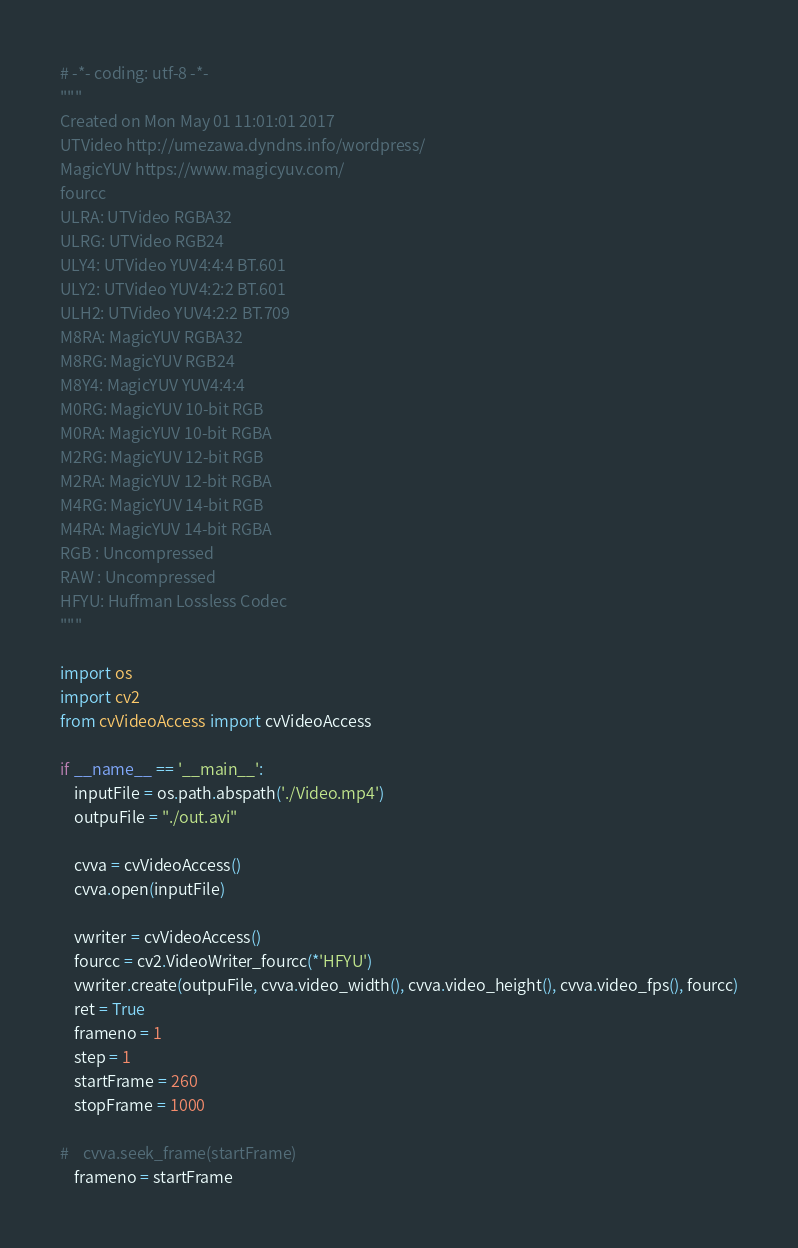Convert code to text. <code><loc_0><loc_0><loc_500><loc_500><_Python_># -*- coding: utf-8 -*-
"""
Created on Mon May 01 11:01:01 2017
UTVideo http://umezawa.dyndns.info/wordpress/
MagicYUV https://www.magicyuv.com/
fourcc 
ULRA: UTVideo RGBA32
ULRG: UTVideo RGB24
ULY4: UTVideo YUV4:4:4 BT.601
ULY2: UTVideo YUV4:2:2 BT.601
ULH2: UTVideo YUV4:2:2 BT.709
M8RA: MagicYUV RGBA32
M8RG: MagicYUV RGB24
M8Y4: MagicYUV YUV4:4:4
M0RG: MagicYUV 10-bit RGB
M0RA: MagicYUV 10-bit RGBA
M2RG: MagicYUV 12-bit RGB
M2RA: MagicYUV 12-bit RGBA
M4RG: MagicYUV 14-bit RGB
M4RA: MagicYUV 14-bit RGBA
RGB : Uncompressed
RAW : Uncompressed
HFYU: Huffman Lossless Codec
"""

import os
import cv2
from cvVideoAccess import cvVideoAccess

if __name__ == '__main__':
    inputFile = os.path.abspath('./Video.mp4')
    outpuFile = "./out.avi"

    cvva = cvVideoAccess()
    cvva.open(inputFile)

    vwriter = cvVideoAccess()
    fourcc = cv2.VideoWriter_fourcc(*'HFYU')
    vwriter.create(outpuFile, cvva.video_width(), cvva.video_height(), cvva.video_fps(), fourcc)
    ret = True
    frameno = 1
    step = 1
    startFrame = 260
    stopFrame = 1000

#    cvva.seek_frame(startFrame)
    frameno = startFrame</code> 